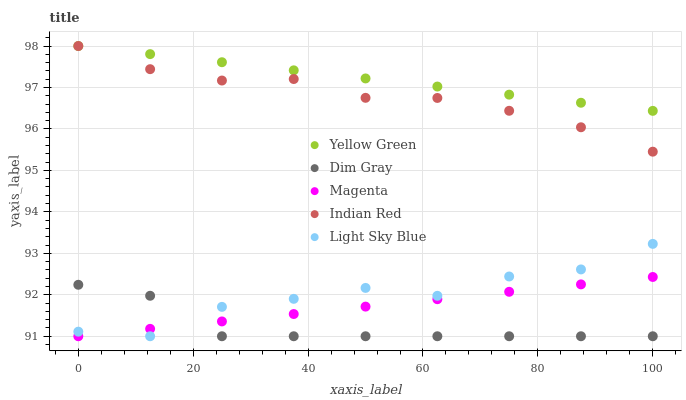Does Dim Gray have the minimum area under the curve?
Answer yes or no. Yes. Does Yellow Green have the maximum area under the curve?
Answer yes or no. Yes. Does Yellow Green have the minimum area under the curve?
Answer yes or no. No. Does Dim Gray have the maximum area under the curve?
Answer yes or no. No. Is Magenta the smoothest?
Answer yes or no. Yes. Is Light Sky Blue the roughest?
Answer yes or no. Yes. Is Dim Gray the smoothest?
Answer yes or no. No. Is Dim Gray the roughest?
Answer yes or no. No. Does Magenta have the lowest value?
Answer yes or no. Yes. Does Yellow Green have the lowest value?
Answer yes or no. No. Does Indian Red have the highest value?
Answer yes or no. Yes. Does Dim Gray have the highest value?
Answer yes or no. No. Is Light Sky Blue less than Yellow Green?
Answer yes or no. Yes. Is Indian Red greater than Light Sky Blue?
Answer yes or no. Yes. Does Indian Red intersect Yellow Green?
Answer yes or no. Yes. Is Indian Red less than Yellow Green?
Answer yes or no. No. Is Indian Red greater than Yellow Green?
Answer yes or no. No. Does Light Sky Blue intersect Yellow Green?
Answer yes or no. No. 